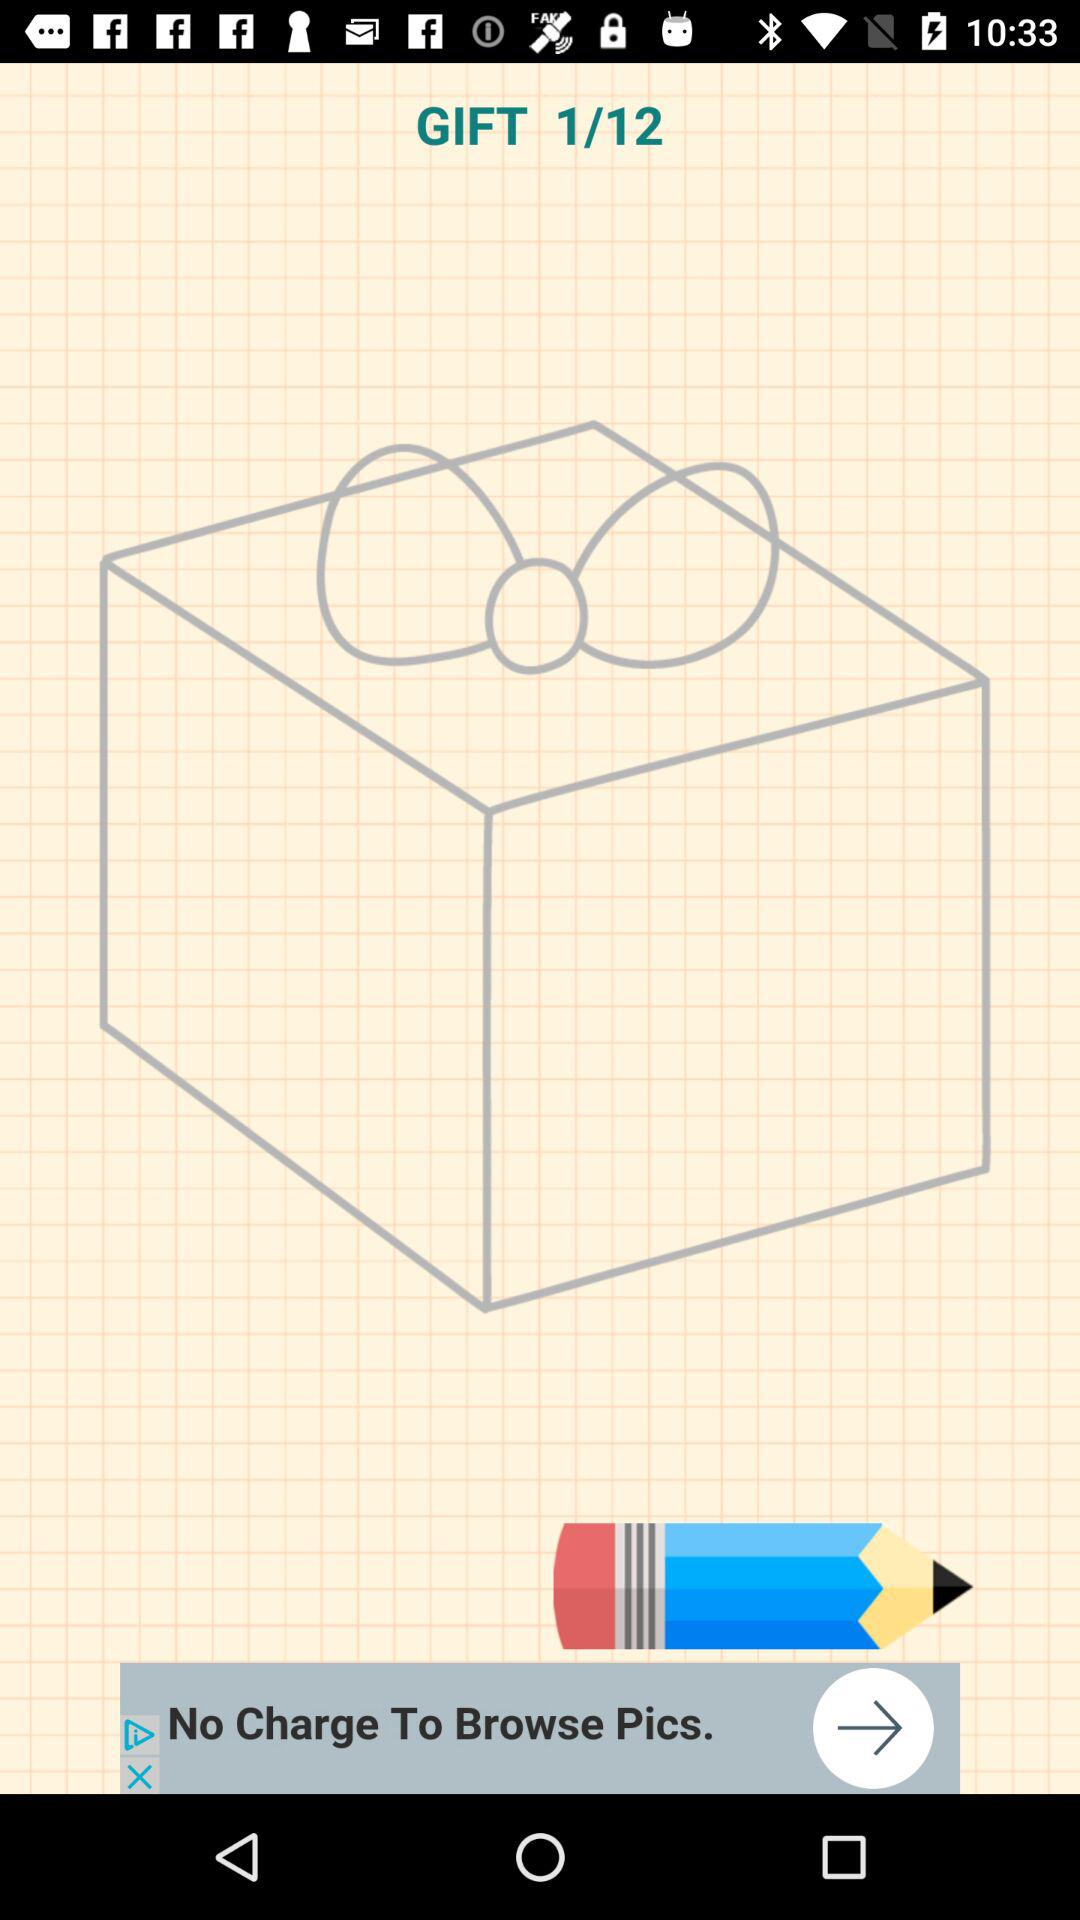Which is the current step number? The current step number is 1. 